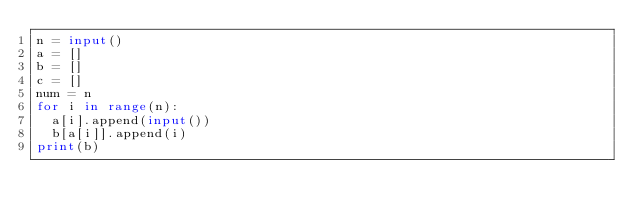Convert code to text. <code><loc_0><loc_0><loc_500><loc_500><_Python_>n = input()
a = []
b = []
c = []
num = n
for i in range(n):
  a[i].append(input())
  b[a[i]].append(i)
print(b)
  </code> 